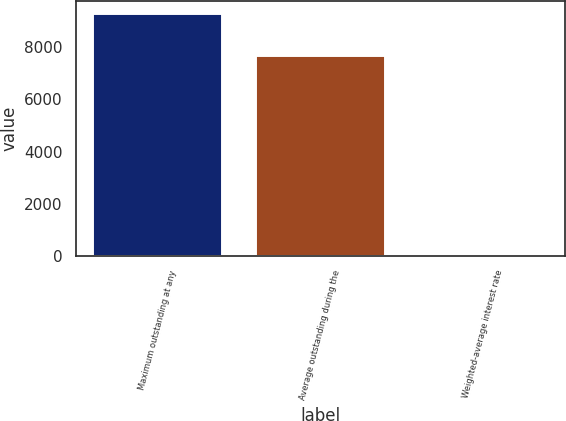Convert chart to OTSL. <chart><loc_0><loc_0><loc_500><loc_500><bar_chart><fcel>Maximum outstanding at any<fcel>Average outstanding during the<fcel>Weighted-average interest rate<nl><fcel>9306<fcel>7697<fcel>0.01<nl></chart> 